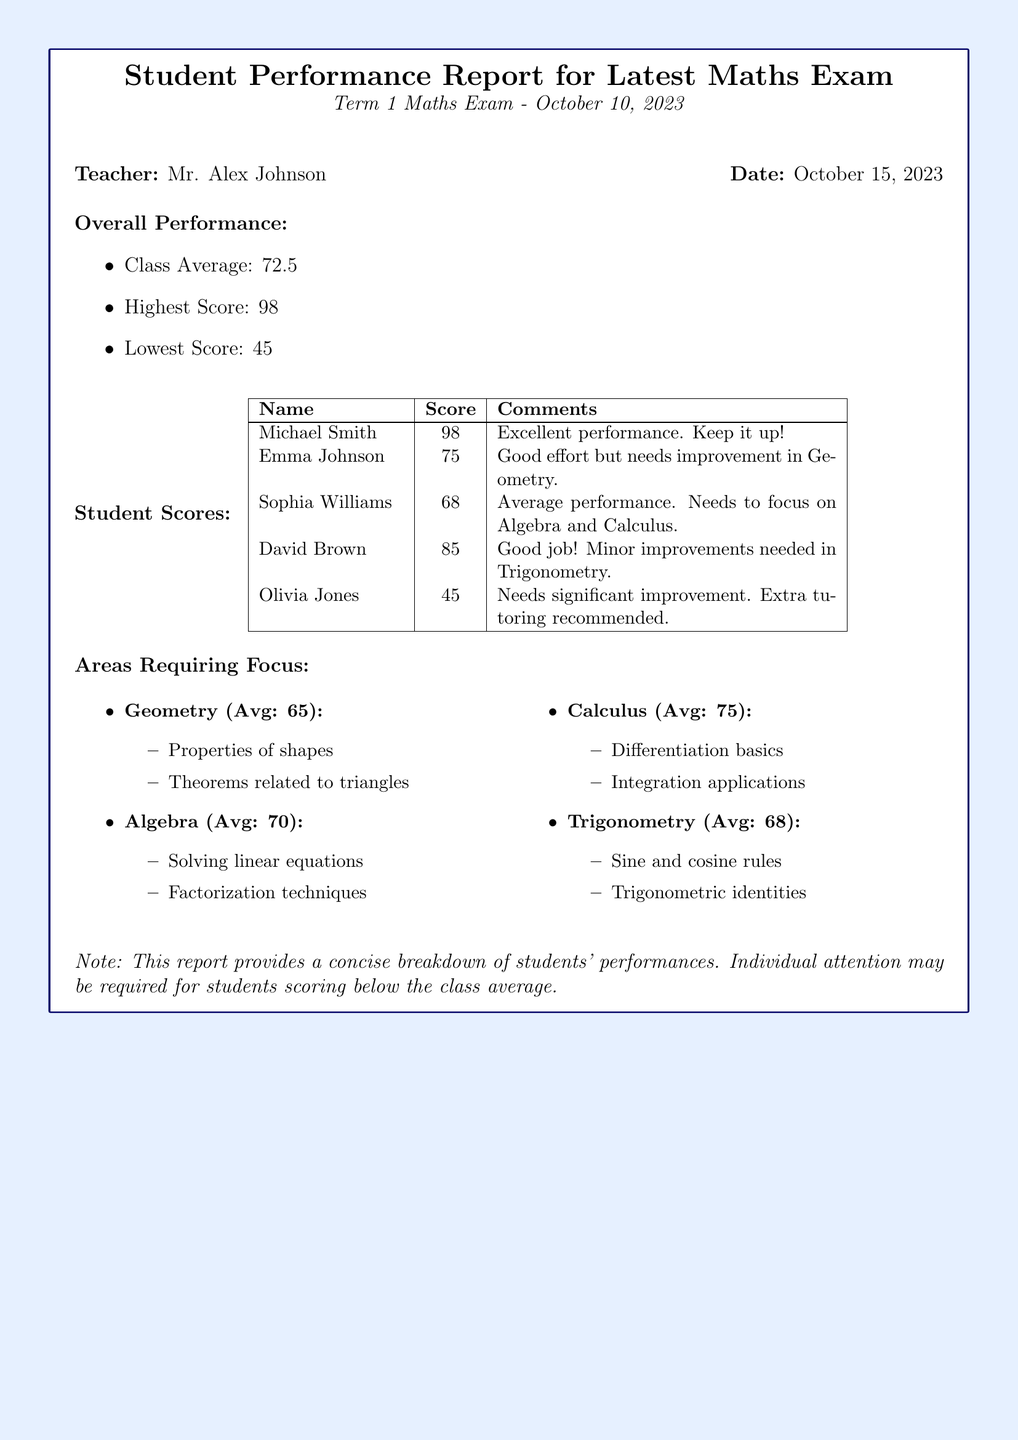What is the teacher's name? The teacher's name is mentioned at the top of the report under the Teacher section.
Answer: Mr. Alex Johnson What is the date of the exam? The date of the exam is specified in the title of the report.
Answer: October 10, 2023 What is the class average score? The class average is provided under the Overall Performance section.
Answer: 72.5 Who scored the lowest in the exam? The student with the lowest score is listed in the Student Scores table.
Answer: Olivia Jones What area has the highest average score? The areas requiring focus section lists areas along with their average scores.
Answer: Calculus How many students scored above 75? The Student Scores table shows the scores of each student, allowing for a count.
Answer: 2 What is the highest score obtained in the exam? This information is stated in the Overall Performance section of the report.
Answer: 98 What comment is given for Sophia Williams? The comments for each student are included in the Student Scores table.
Answer: Average performance. Needs to focus on Algebra and Calculus Which topic in Geometry requires focus? The areas requiring focus section lists topics under Geometry that need attention.
Answer: Properties of shapes 